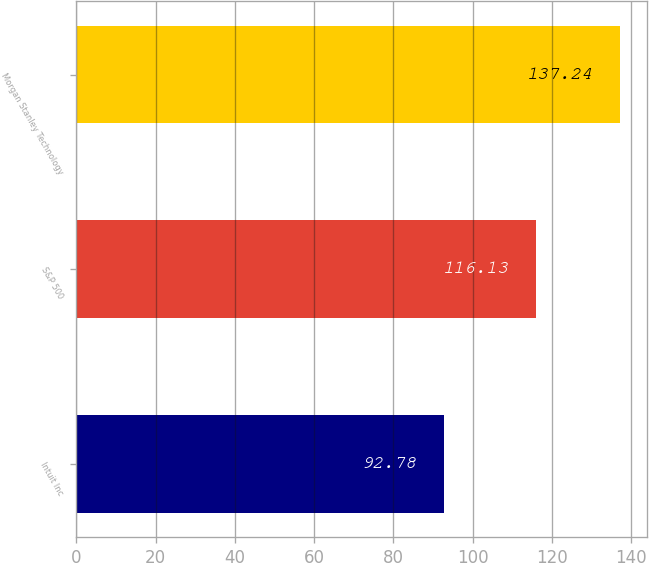<chart> <loc_0><loc_0><loc_500><loc_500><bar_chart><fcel>Intuit Inc<fcel>S&P 500<fcel>Morgan Stanley Technology<nl><fcel>92.78<fcel>116.13<fcel>137.24<nl></chart> 